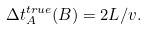<formula> <loc_0><loc_0><loc_500><loc_500>\Delta t _ { A } ^ { t r u e } ( B ) = { 2 L } / { v } .</formula> 